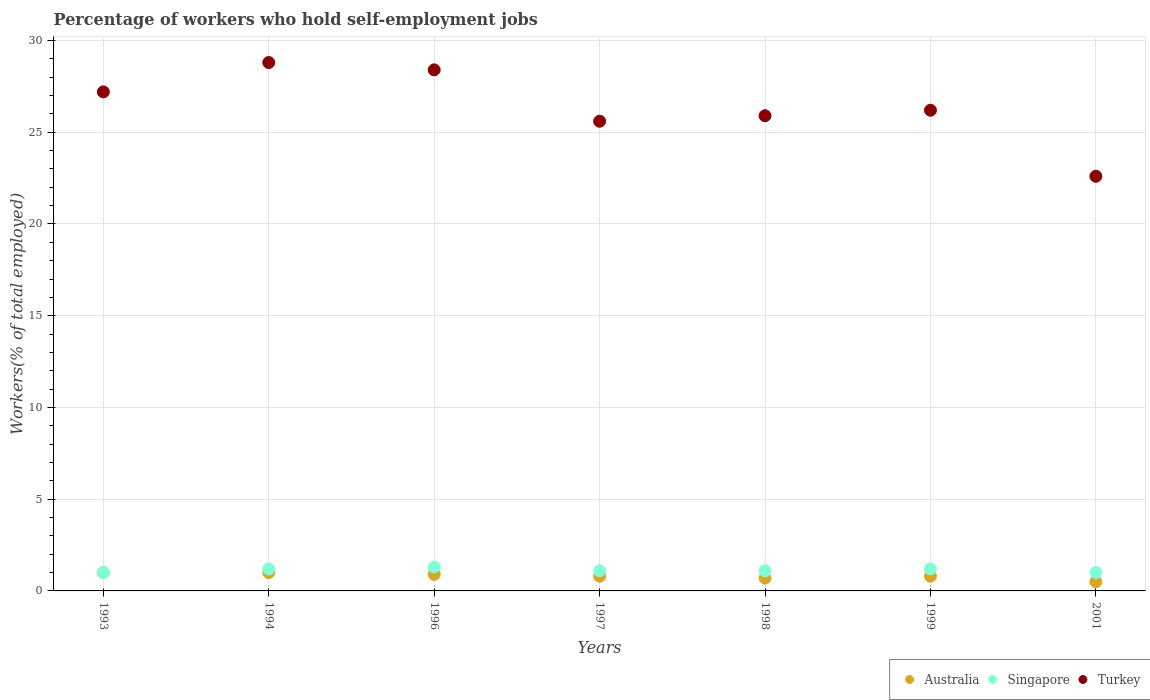How many different coloured dotlines are there?
Offer a terse response. 3. What is the percentage of self-employed workers in Turkey in 1993?
Ensure brevity in your answer.  27.2. Across all years, what is the maximum percentage of self-employed workers in Singapore?
Keep it short and to the point. 1.3. In which year was the percentage of self-employed workers in Singapore maximum?
Give a very brief answer. 1996. What is the total percentage of self-employed workers in Turkey in the graph?
Provide a succinct answer. 184.7. What is the difference between the percentage of self-employed workers in Singapore in 1993 and that in 1994?
Make the answer very short. -0.2. What is the difference between the percentage of self-employed workers in Australia in 1998 and the percentage of self-employed workers in Turkey in 1994?
Your answer should be very brief. -28.1. What is the average percentage of self-employed workers in Australia per year?
Provide a short and direct response. 0.81. In the year 1996, what is the difference between the percentage of self-employed workers in Australia and percentage of self-employed workers in Singapore?
Offer a very short reply. -0.4. In how many years, is the percentage of self-employed workers in Singapore greater than 13 %?
Offer a terse response. 0. What is the ratio of the percentage of self-employed workers in Turkey in 1999 to that in 2001?
Offer a very short reply. 1.16. Is the percentage of self-employed workers in Turkey in 1996 less than that in 2001?
Ensure brevity in your answer.  No. What is the difference between the highest and the second highest percentage of self-employed workers in Australia?
Ensure brevity in your answer.  0. What is the difference between the highest and the lowest percentage of self-employed workers in Singapore?
Ensure brevity in your answer.  0.3. Is it the case that in every year, the sum of the percentage of self-employed workers in Turkey and percentage of self-employed workers in Australia  is greater than the percentage of self-employed workers in Singapore?
Your response must be concise. Yes. Does the percentage of self-employed workers in Australia monotonically increase over the years?
Provide a succinct answer. No. Is the percentage of self-employed workers in Singapore strictly greater than the percentage of self-employed workers in Australia over the years?
Your answer should be very brief. No. How many years are there in the graph?
Provide a succinct answer. 7. What is the difference between two consecutive major ticks on the Y-axis?
Give a very brief answer. 5. Does the graph contain grids?
Provide a succinct answer. Yes. Where does the legend appear in the graph?
Your answer should be compact. Bottom right. What is the title of the graph?
Ensure brevity in your answer.  Percentage of workers who hold self-employment jobs. What is the label or title of the X-axis?
Your answer should be compact. Years. What is the label or title of the Y-axis?
Keep it short and to the point. Workers(% of total employed). What is the Workers(% of total employed) in Singapore in 1993?
Keep it short and to the point. 1. What is the Workers(% of total employed) of Turkey in 1993?
Your answer should be very brief. 27.2. What is the Workers(% of total employed) of Singapore in 1994?
Provide a succinct answer. 1.2. What is the Workers(% of total employed) of Turkey in 1994?
Ensure brevity in your answer.  28.8. What is the Workers(% of total employed) of Australia in 1996?
Provide a succinct answer. 0.9. What is the Workers(% of total employed) in Singapore in 1996?
Your response must be concise. 1.3. What is the Workers(% of total employed) in Turkey in 1996?
Offer a terse response. 28.4. What is the Workers(% of total employed) of Australia in 1997?
Your response must be concise. 0.8. What is the Workers(% of total employed) in Singapore in 1997?
Provide a short and direct response. 1.1. What is the Workers(% of total employed) of Turkey in 1997?
Keep it short and to the point. 25.6. What is the Workers(% of total employed) in Australia in 1998?
Provide a short and direct response. 0.7. What is the Workers(% of total employed) of Singapore in 1998?
Offer a terse response. 1.1. What is the Workers(% of total employed) in Turkey in 1998?
Your response must be concise. 25.9. What is the Workers(% of total employed) of Australia in 1999?
Your answer should be very brief. 0.8. What is the Workers(% of total employed) in Singapore in 1999?
Your response must be concise. 1.2. What is the Workers(% of total employed) in Turkey in 1999?
Provide a succinct answer. 26.2. What is the Workers(% of total employed) in Australia in 2001?
Offer a terse response. 0.5. What is the Workers(% of total employed) in Singapore in 2001?
Give a very brief answer. 1. What is the Workers(% of total employed) in Turkey in 2001?
Your answer should be very brief. 22.6. Across all years, what is the maximum Workers(% of total employed) in Singapore?
Provide a succinct answer. 1.3. Across all years, what is the maximum Workers(% of total employed) in Turkey?
Keep it short and to the point. 28.8. Across all years, what is the minimum Workers(% of total employed) of Singapore?
Ensure brevity in your answer.  1. Across all years, what is the minimum Workers(% of total employed) of Turkey?
Offer a terse response. 22.6. What is the total Workers(% of total employed) in Australia in the graph?
Keep it short and to the point. 5.7. What is the total Workers(% of total employed) of Singapore in the graph?
Make the answer very short. 7.9. What is the total Workers(% of total employed) of Turkey in the graph?
Your answer should be compact. 184.7. What is the difference between the Workers(% of total employed) in Australia in 1993 and that in 1994?
Your answer should be very brief. 0. What is the difference between the Workers(% of total employed) in Turkey in 1993 and that in 1994?
Your response must be concise. -1.6. What is the difference between the Workers(% of total employed) of Turkey in 1993 and that in 1996?
Your response must be concise. -1.2. What is the difference between the Workers(% of total employed) of Turkey in 1993 and that in 1998?
Offer a terse response. 1.3. What is the difference between the Workers(% of total employed) in Australia in 1993 and that in 2001?
Ensure brevity in your answer.  0.5. What is the difference between the Workers(% of total employed) of Australia in 1994 and that in 1996?
Your response must be concise. 0.1. What is the difference between the Workers(% of total employed) of Singapore in 1994 and that in 1996?
Offer a very short reply. -0.1. What is the difference between the Workers(% of total employed) in Turkey in 1994 and that in 1996?
Your response must be concise. 0.4. What is the difference between the Workers(% of total employed) in Australia in 1994 and that in 1997?
Provide a succinct answer. 0.2. What is the difference between the Workers(% of total employed) of Singapore in 1994 and that in 1997?
Offer a very short reply. 0.1. What is the difference between the Workers(% of total employed) of Turkey in 1994 and that in 1998?
Offer a terse response. 2.9. What is the difference between the Workers(% of total employed) of Australia in 1994 and that in 1999?
Offer a terse response. 0.2. What is the difference between the Workers(% of total employed) of Turkey in 1994 and that in 2001?
Give a very brief answer. 6.2. What is the difference between the Workers(% of total employed) in Singapore in 1996 and that in 1997?
Keep it short and to the point. 0.2. What is the difference between the Workers(% of total employed) of Turkey in 1996 and that in 1997?
Your answer should be very brief. 2.8. What is the difference between the Workers(% of total employed) of Australia in 1996 and that in 1998?
Your response must be concise. 0.2. What is the difference between the Workers(% of total employed) of Turkey in 1996 and that in 1998?
Provide a succinct answer. 2.5. What is the difference between the Workers(% of total employed) of Australia in 1996 and that in 1999?
Keep it short and to the point. 0.1. What is the difference between the Workers(% of total employed) of Turkey in 1996 and that in 1999?
Offer a very short reply. 2.2. What is the difference between the Workers(% of total employed) in Singapore in 1996 and that in 2001?
Your answer should be very brief. 0.3. What is the difference between the Workers(% of total employed) of Turkey in 1996 and that in 2001?
Your answer should be very brief. 5.8. What is the difference between the Workers(% of total employed) of Australia in 1997 and that in 2001?
Offer a terse response. 0.3. What is the difference between the Workers(% of total employed) in Turkey in 1997 and that in 2001?
Ensure brevity in your answer.  3. What is the difference between the Workers(% of total employed) in Australia in 1998 and that in 1999?
Keep it short and to the point. -0.1. What is the difference between the Workers(% of total employed) of Singapore in 1998 and that in 1999?
Your answer should be very brief. -0.1. What is the difference between the Workers(% of total employed) in Turkey in 1998 and that in 1999?
Keep it short and to the point. -0.3. What is the difference between the Workers(% of total employed) in Turkey in 1998 and that in 2001?
Keep it short and to the point. 3.3. What is the difference between the Workers(% of total employed) in Australia in 1999 and that in 2001?
Your answer should be compact. 0.3. What is the difference between the Workers(% of total employed) in Australia in 1993 and the Workers(% of total employed) in Singapore in 1994?
Your response must be concise. -0.2. What is the difference between the Workers(% of total employed) in Australia in 1993 and the Workers(% of total employed) in Turkey in 1994?
Give a very brief answer. -27.8. What is the difference between the Workers(% of total employed) in Singapore in 1993 and the Workers(% of total employed) in Turkey in 1994?
Ensure brevity in your answer.  -27.8. What is the difference between the Workers(% of total employed) of Australia in 1993 and the Workers(% of total employed) of Turkey in 1996?
Ensure brevity in your answer.  -27.4. What is the difference between the Workers(% of total employed) of Singapore in 1993 and the Workers(% of total employed) of Turkey in 1996?
Your answer should be very brief. -27.4. What is the difference between the Workers(% of total employed) in Australia in 1993 and the Workers(% of total employed) in Singapore in 1997?
Your answer should be compact. -0.1. What is the difference between the Workers(% of total employed) in Australia in 1993 and the Workers(% of total employed) in Turkey in 1997?
Offer a terse response. -24.6. What is the difference between the Workers(% of total employed) in Singapore in 1993 and the Workers(% of total employed) in Turkey in 1997?
Your answer should be very brief. -24.6. What is the difference between the Workers(% of total employed) in Australia in 1993 and the Workers(% of total employed) in Singapore in 1998?
Offer a terse response. -0.1. What is the difference between the Workers(% of total employed) in Australia in 1993 and the Workers(% of total employed) in Turkey in 1998?
Offer a very short reply. -24.9. What is the difference between the Workers(% of total employed) of Singapore in 1993 and the Workers(% of total employed) of Turkey in 1998?
Keep it short and to the point. -24.9. What is the difference between the Workers(% of total employed) of Australia in 1993 and the Workers(% of total employed) of Singapore in 1999?
Offer a very short reply. -0.2. What is the difference between the Workers(% of total employed) in Australia in 1993 and the Workers(% of total employed) in Turkey in 1999?
Ensure brevity in your answer.  -25.2. What is the difference between the Workers(% of total employed) of Singapore in 1993 and the Workers(% of total employed) of Turkey in 1999?
Your response must be concise. -25.2. What is the difference between the Workers(% of total employed) of Australia in 1993 and the Workers(% of total employed) of Turkey in 2001?
Ensure brevity in your answer.  -21.6. What is the difference between the Workers(% of total employed) of Singapore in 1993 and the Workers(% of total employed) of Turkey in 2001?
Your answer should be very brief. -21.6. What is the difference between the Workers(% of total employed) in Australia in 1994 and the Workers(% of total employed) in Turkey in 1996?
Keep it short and to the point. -27.4. What is the difference between the Workers(% of total employed) in Singapore in 1994 and the Workers(% of total employed) in Turkey in 1996?
Give a very brief answer. -27.2. What is the difference between the Workers(% of total employed) of Australia in 1994 and the Workers(% of total employed) of Turkey in 1997?
Your response must be concise. -24.6. What is the difference between the Workers(% of total employed) in Singapore in 1994 and the Workers(% of total employed) in Turkey in 1997?
Ensure brevity in your answer.  -24.4. What is the difference between the Workers(% of total employed) in Australia in 1994 and the Workers(% of total employed) in Turkey in 1998?
Your answer should be very brief. -24.9. What is the difference between the Workers(% of total employed) of Singapore in 1994 and the Workers(% of total employed) of Turkey in 1998?
Offer a terse response. -24.7. What is the difference between the Workers(% of total employed) in Australia in 1994 and the Workers(% of total employed) in Turkey in 1999?
Offer a terse response. -25.2. What is the difference between the Workers(% of total employed) of Singapore in 1994 and the Workers(% of total employed) of Turkey in 1999?
Provide a short and direct response. -25. What is the difference between the Workers(% of total employed) in Australia in 1994 and the Workers(% of total employed) in Turkey in 2001?
Make the answer very short. -21.6. What is the difference between the Workers(% of total employed) of Singapore in 1994 and the Workers(% of total employed) of Turkey in 2001?
Provide a short and direct response. -21.4. What is the difference between the Workers(% of total employed) in Australia in 1996 and the Workers(% of total employed) in Singapore in 1997?
Offer a very short reply. -0.2. What is the difference between the Workers(% of total employed) in Australia in 1996 and the Workers(% of total employed) in Turkey in 1997?
Give a very brief answer. -24.7. What is the difference between the Workers(% of total employed) of Singapore in 1996 and the Workers(% of total employed) of Turkey in 1997?
Your answer should be very brief. -24.3. What is the difference between the Workers(% of total employed) of Australia in 1996 and the Workers(% of total employed) of Singapore in 1998?
Your answer should be very brief. -0.2. What is the difference between the Workers(% of total employed) of Australia in 1996 and the Workers(% of total employed) of Turkey in 1998?
Provide a succinct answer. -25. What is the difference between the Workers(% of total employed) in Singapore in 1996 and the Workers(% of total employed) in Turkey in 1998?
Ensure brevity in your answer.  -24.6. What is the difference between the Workers(% of total employed) of Australia in 1996 and the Workers(% of total employed) of Singapore in 1999?
Make the answer very short. -0.3. What is the difference between the Workers(% of total employed) of Australia in 1996 and the Workers(% of total employed) of Turkey in 1999?
Make the answer very short. -25.3. What is the difference between the Workers(% of total employed) of Singapore in 1996 and the Workers(% of total employed) of Turkey in 1999?
Your response must be concise. -24.9. What is the difference between the Workers(% of total employed) in Australia in 1996 and the Workers(% of total employed) in Turkey in 2001?
Make the answer very short. -21.7. What is the difference between the Workers(% of total employed) of Singapore in 1996 and the Workers(% of total employed) of Turkey in 2001?
Keep it short and to the point. -21.3. What is the difference between the Workers(% of total employed) of Australia in 1997 and the Workers(% of total employed) of Singapore in 1998?
Offer a terse response. -0.3. What is the difference between the Workers(% of total employed) of Australia in 1997 and the Workers(% of total employed) of Turkey in 1998?
Keep it short and to the point. -25.1. What is the difference between the Workers(% of total employed) of Singapore in 1997 and the Workers(% of total employed) of Turkey in 1998?
Give a very brief answer. -24.8. What is the difference between the Workers(% of total employed) of Australia in 1997 and the Workers(% of total employed) of Turkey in 1999?
Make the answer very short. -25.4. What is the difference between the Workers(% of total employed) of Singapore in 1997 and the Workers(% of total employed) of Turkey in 1999?
Your response must be concise. -25.1. What is the difference between the Workers(% of total employed) in Australia in 1997 and the Workers(% of total employed) in Turkey in 2001?
Offer a very short reply. -21.8. What is the difference between the Workers(% of total employed) in Singapore in 1997 and the Workers(% of total employed) in Turkey in 2001?
Keep it short and to the point. -21.5. What is the difference between the Workers(% of total employed) in Australia in 1998 and the Workers(% of total employed) in Turkey in 1999?
Your answer should be very brief. -25.5. What is the difference between the Workers(% of total employed) in Singapore in 1998 and the Workers(% of total employed) in Turkey in 1999?
Offer a very short reply. -25.1. What is the difference between the Workers(% of total employed) of Australia in 1998 and the Workers(% of total employed) of Turkey in 2001?
Ensure brevity in your answer.  -21.9. What is the difference between the Workers(% of total employed) of Singapore in 1998 and the Workers(% of total employed) of Turkey in 2001?
Provide a short and direct response. -21.5. What is the difference between the Workers(% of total employed) in Australia in 1999 and the Workers(% of total employed) in Turkey in 2001?
Make the answer very short. -21.8. What is the difference between the Workers(% of total employed) of Singapore in 1999 and the Workers(% of total employed) of Turkey in 2001?
Provide a short and direct response. -21.4. What is the average Workers(% of total employed) of Australia per year?
Your response must be concise. 0.81. What is the average Workers(% of total employed) of Singapore per year?
Give a very brief answer. 1.13. What is the average Workers(% of total employed) of Turkey per year?
Offer a very short reply. 26.39. In the year 1993, what is the difference between the Workers(% of total employed) of Australia and Workers(% of total employed) of Turkey?
Offer a terse response. -26.2. In the year 1993, what is the difference between the Workers(% of total employed) of Singapore and Workers(% of total employed) of Turkey?
Your response must be concise. -26.2. In the year 1994, what is the difference between the Workers(% of total employed) of Australia and Workers(% of total employed) of Turkey?
Give a very brief answer. -27.8. In the year 1994, what is the difference between the Workers(% of total employed) of Singapore and Workers(% of total employed) of Turkey?
Offer a terse response. -27.6. In the year 1996, what is the difference between the Workers(% of total employed) in Australia and Workers(% of total employed) in Singapore?
Your answer should be compact. -0.4. In the year 1996, what is the difference between the Workers(% of total employed) of Australia and Workers(% of total employed) of Turkey?
Your response must be concise. -27.5. In the year 1996, what is the difference between the Workers(% of total employed) in Singapore and Workers(% of total employed) in Turkey?
Your answer should be very brief. -27.1. In the year 1997, what is the difference between the Workers(% of total employed) in Australia and Workers(% of total employed) in Turkey?
Make the answer very short. -24.8. In the year 1997, what is the difference between the Workers(% of total employed) in Singapore and Workers(% of total employed) in Turkey?
Make the answer very short. -24.5. In the year 1998, what is the difference between the Workers(% of total employed) in Australia and Workers(% of total employed) in Turkey?
Provide a short and direct response. -25.2. In the year 1998, what is the difference between the Workers(% of total employed) in Singapore and Workers(% of total employed) in Turkey?
Offer a terse response. -24.8. In the year 1999, what is the difference between the Workers(% of total employed) of Australia and Workers(% of total employed) of Singapore?
Keep it short and to the point. -0.4. In the year 1999, what is the difference between the Workers(% of total employed) in Australia and Workers(% of total employed) in Turkey?
Make the answer very short. -25.4. In the year 1999, what is the difference between the Workers(% of total employed) of Singapore and Workers(% of total employed) of Turkey?
Keep it short and to the point. -25. In the year 2001, what is the difference between the Workers(% of total employed) in Australia and Workers(% of total employed) in Singapore?
Ensure brevity in your answer.  -0.5. In the year 2001, what is the difference between the Workers(% of total employed) of Australia and Workers(% of total employed) of Turkey?
Offer a terse response. -22.1. In the year 2001, what is the difference between the Workers(% of total employed) of Singapore and Workers(% of total employed) of Turkey?
Provide a short and direct response. -21.6. What is the ratio of the Workers(% of total employed) of Australia in 1993 to that in 1994?
Ensure brevity in your answer.  1. What is the ratio of the Workers(% of total employed) of Singapore in 1993 to that in 1994?
Your answer should be very brief. 0.83. What is the ratio of the Workers(% of total employed) in Turkey in 1993 to that in 1994?
Keep it short and to the point. 0.94. What is the ratio of the Workers(% of total employed) of Australia in 1993 to that in 1996?
Provide a succinct answer. 1.11. What is the ratio of the Workers(% of total employed) in Singapore in 1993 to that in 1996?
Make the answer very short. 0.77. What is the ratio of the Workers(% of total employed) in Turkey in 1993 to that in 1996?
Give a very brief answer. 0.96. What is the ratio of the Workers(% of total employed) of Australia in 1993 to that in 1997?
Your answer should be very brief. 1.25. What is the ratio of the Workers(% of total employed) in Singapore in 1993 to that in 1997?
Make the answer very short. 0.91. What is the ratio of the Workers(% of total employed) of Turkey in 1993 to that in 1997?
Your answer should be very brief. 1.06. What is the ratio of the Workers(% of total employed) of Australia in 1993 to that in 1998?
Ensure brevity in your answer.  1.43. What is the ratio of the Workers(% of total employed) of Turkey in 1993 to that in 1998?
Your response must be concise. 1.05. What is the ratio of the Workers(% of total employed) of Turkey in 1993 to that in 1999?
Offer a terse response. 1.04. What is the ratio of the Workers(% of total employed) of Turkey in 1993 to that in 2001?
Offer a terse response. 1.2. What is the ratio of the Workers(% of total employed) in Australia in 1994 to that in 1996?
Your response must be concise. 1.11. What is the ratio of the Workers(% of total employed) in Singapore in 1994 to that in 1996?
Your answer should be compact. 0.92. What is the ratio of the Workers(% of total employed) in Turkey in 1994 to that in 1996?
Give a very brief answer. 1.01. What is the ratio of the Workers(% of total employed) in Australia in 1994 to that in 1997?
Make the answer very short. 1.25. What is the ratio of the Workers(% of total employed) of Singapore in 1994 to that in 1997?
Your answer should be very brief. 1.09. What is the ratio of the Workers(% of total employed) of Turkey in 1994 to that in 1997?
Your answer should be compact. 1.12. What is the ratio of the Workers(% of total employed) in Australia in 1994 to that in 1998?
Offer a terse response. 1.43. What is the ratio of the Workers(% of total employed) in Turkey in 1994 to that in 1998?
Offer a terse response. 1.11. What is the ratio of the Workers(% of total employed) in Australia in 1994 to that in 1999?
Your answer should be very brief. 1.25. What is the ratio of the Workers(% of total employed) of Turkey in 1994 to that in 1999?
Your answer should be compact. 1.1. What is the ratio of the Workers(% of total employed) in Australia in 1994 to that in 2001?
Your answer should be compact. 2. What is the ratio of the Workers(% of total employed) of Turkey in 1994 to that in 2001?
Provide a short and direct response. 1.27. What is the ratio of the Workers(% of total employed) in Singapore in 1996 to that in 1997?
Your answer should be very brief. 1.18. What is the ratio of the Workers(% of total employed) of Turkey in 1996 to that in 1997?
Provide a short and direct response. 1.11. What is the ratio of the Workers(% of total employed) of Australia in 1996 to that in 1998?
Give a very brief answer. 1.29. What is the ratio of the Workers(% of total employed) of Singapore in 1996 to that in 1998?
Offer a very short reply. 1.18. What is the ratio of the Workers(% of total employed) in Turkey in 1996 to that in 1998?
Offer a terse response. 1.1. What is the ratio of the Workers(% of total employed) of Turkey in 1996 to that in 1999?
Offer a terse response. 1.08. What is the ratio of the Workers(% of total employed) of Australia in 1996 to that in 2001?
Make the answer very short. 1.8. What is the ratio of the Workers(% of total employed) in Turkey in 1996 to that in 2001?
Provide a succinct answer. 1.26. What is the ratio of the Workers(% of total employed) in Australia in 1997 to that in 1998?
Provide a succinct answer. 1.14. What is the ratio of the Workers(% of total employed) in Turkey in 1997 to that in 1998?
Provide a short and direct response. 0.99. What is the ratio of the Workers(% of total employed) of Australia in 1997 to that in 1999?
Ensure brevity in your answer.  1. What is the ratio of the Workers(% of total employed) in Turkey in 1997 to that in 1999?
Give a very brief answer. 0.98. What is the ratio of the Workers(% of total employed) in Australia in 1997 to that in 2001?
Provide a short and direct response. 1.6. What is the ratio of the Workers(% of total employed) in Turkey in 1997 to that in 2001?
Make the answer very short. 1.13. What is the ratio of the Workers(% of total employed) in Singapore in 1998 to that in 1999?
Provide a succinct answer. 0.92. What is the ratio of the Workers(% of total employed) of Turkey in 1998 to that in 1999?
Your response must be concise. 0.99. What is the ratio of the Workers(% of total employed) of Australia in 1998 to that in 2001?
Give a very brief answer. 1.4. What is the ratio of the Workers(% of total employed) in Singapore in 1998 to that in 2001?
Your answer should be compact. 1.1. What is the ratio of the Workers(% of total employed) of Turkey in 1998 to that in 2001?
Your response must be concise. 1.15. What is the ratio of the Workers(% of total employed) of Australia in 1999 to that in 2001?
Make the answer very short. 1.6. What is the ratio of the Workers(% of total employed) in Turkey in 1999 to that in 2001?
Your answer should be compact. 1.16. What is the difference between the highest and the lowest Workers(% of total employed) in Singapore?
Ensure brevity in your answer.  0.3. What is the difference between the highest and the lowest Workers(% of total employed) in Turkey?
Ensure brevity in your answer.  6.2. 